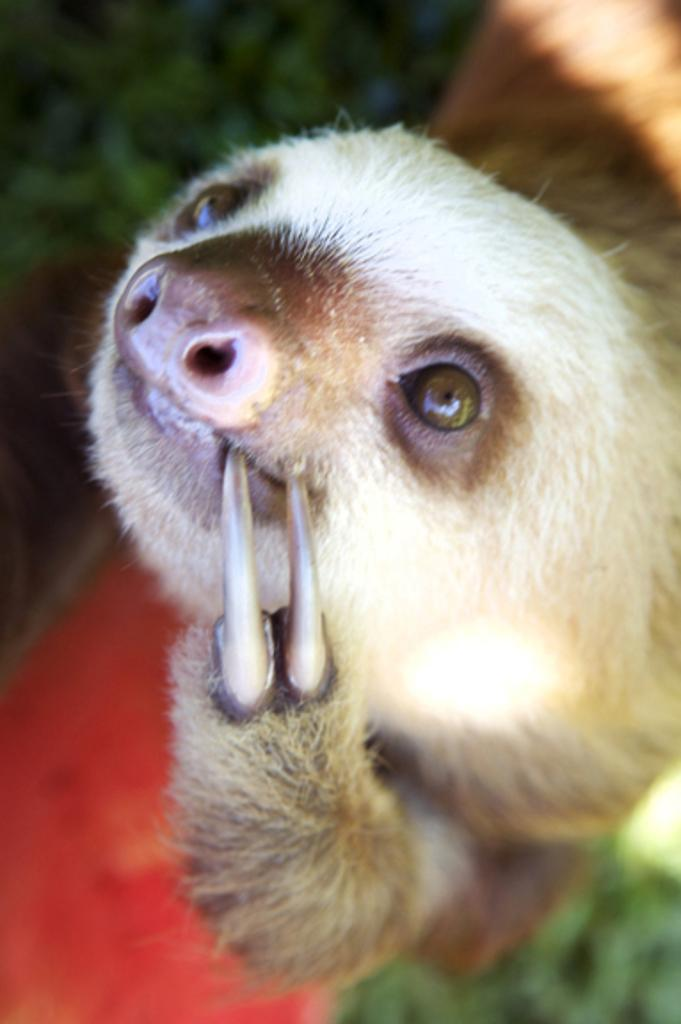What can be observed about the background of the image? The background of the image is blurred. What is the main subject in the middle of the image? There is an animal in the middle of the image. What type of vegetable is being used as a prop by the animal in the image? There is no vegetable present in the image, and the animal is not using any props. 